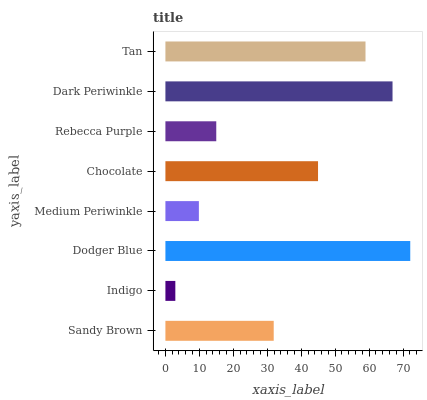Is Indigo the minimum?
Answer yes or no. Yes. Is Dodger Blue the maximum?
Answer yes or no. Yes. Is Dodger Blue the minimum?
Answer yes or no. No. Is Indigo the maximum?
Answer yes or no. No. Is Dodger Blue greater than Indigo?
Answer yes or no. Yes. Is Indigo less than Dodger Blue?
Answer yes or no. Yes. Is Indigo greater than Dodger Blue?
Answer yes or no. No. Is Dodger Blue less than Indigo?
Answer yes or no. No. Is Chocolate the high median?
Answer yes or no. Yes. Is Sandy Brown the low median?
Answer yes or no. Yes. Is Indigo the high median?
Answer yes or no. No. Is Medium Periwinkle the low median?
Answer yes or no. No. 